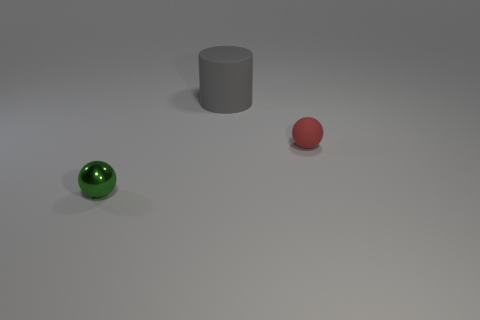Add 3 tiny rubber balls. How many objects exist? 6 Subtract all red spheres. How many spheres are left? 1 Subtract all green spheres. Subtract all blue cylinders. How many spheres are left? 1 Subtract all cyan cubes. How many cyan balls are left? 0 Subtract all cyan matte things. Subtract all cylinders. How many objects are left? 2 Add 2 small red objects. How many small red objects are left? 3 Add 3 red objects. How many red objects exist? 4 Subtract 0 cyan cylinders. How many objects are left? 3 Subtract all cylinders. How many objects are left? 2 